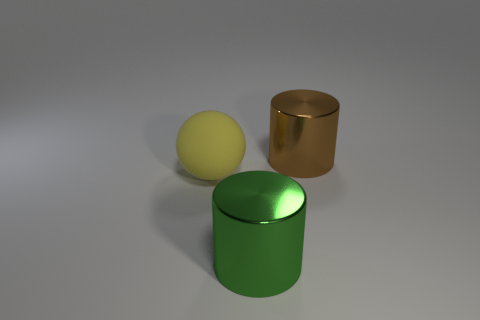How many matte things are to the right of the big yellow matte sphere?
Ensure brevity in your answer.  0. The thing that is both to the left of the brown shiny thing and to the right of the yellow ball is made of what material?
Your answer should be compact. Metal. How many metal things have the same size as the matte ball?
Your response must be concise. 2. What color is the metallic object that is in front of the large yellow matte thing that is behind the green thing?
Your answer should be very brief. Green. Are there any metal things?
Give a very brief answer. Yes. Is the large brown thing the same shape as the green metallic thing?
Provide a short and direct response. Yes. There is a large object behind the yellow sphere; how many large metal objects are in front of it?
Your response must be concise. 1. How many things are behind the green metal thing and on the right side of the yellow rubber ball?
Ensure brevity in your answer.  1. What number of things are either large brown shiny things or large shiny cylinders behind the rubber thing?
Your answer should be compact. 1. The object that is the same material as the brown cylinder is what size?
Keep it short and to the point. Large. 